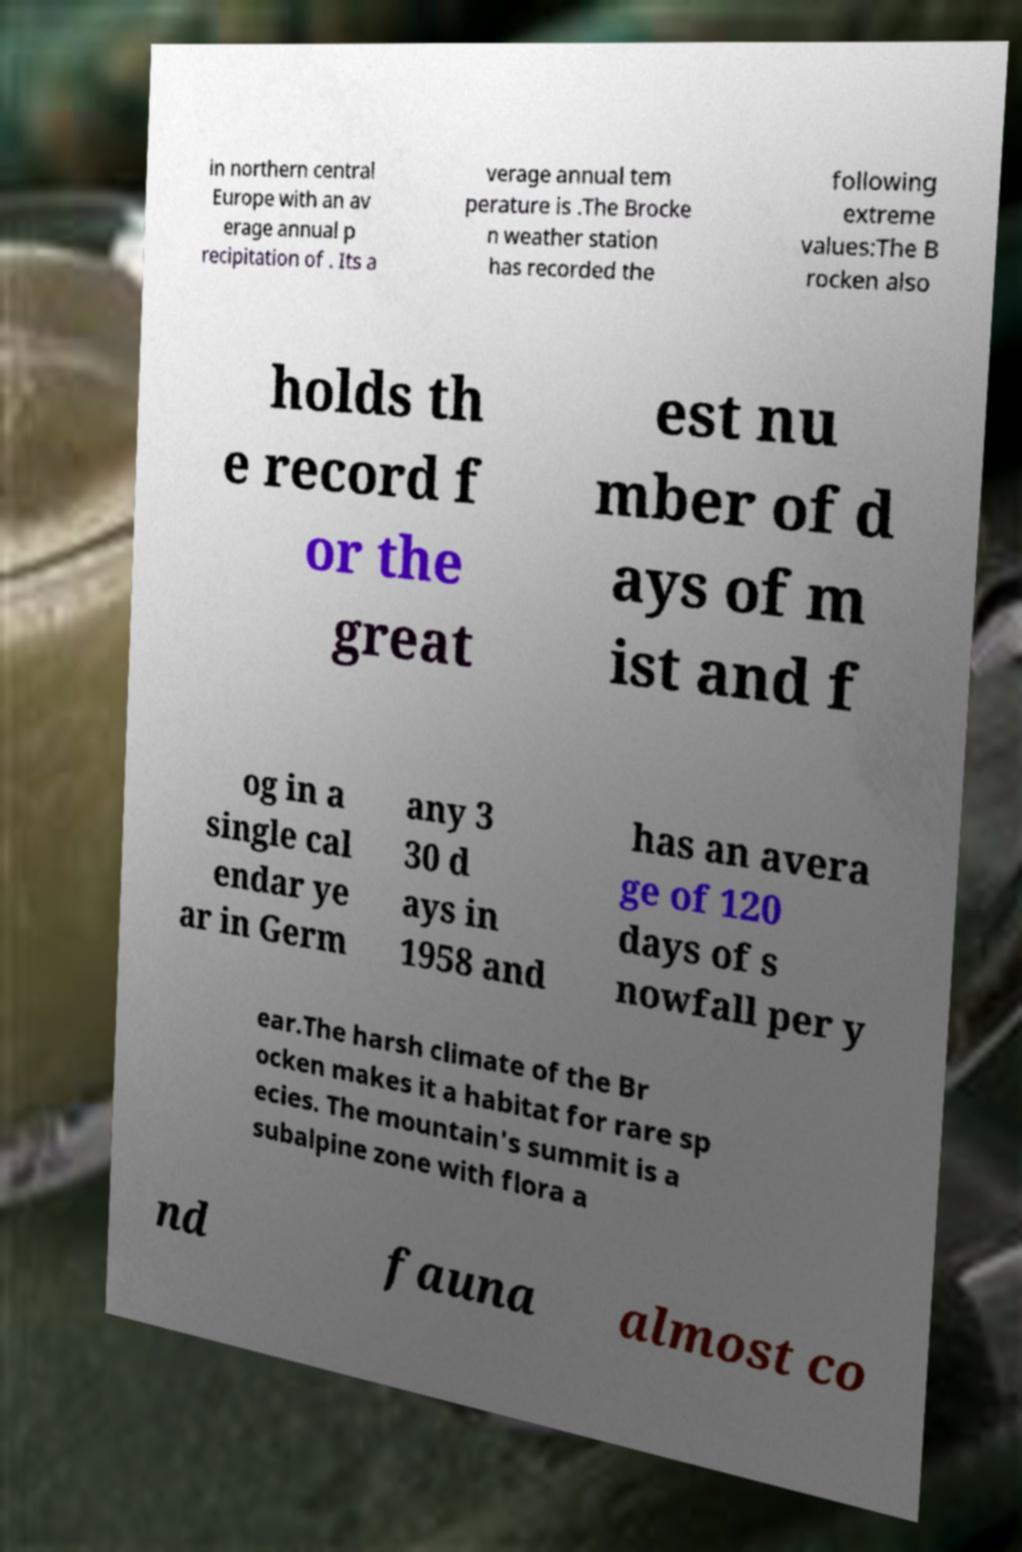Could you extract and type out the text from this image? in northern central Europe with an av erage annual p recipitation of . Its a verage annual tem perature is .The Brocke n weather station has recorded the following extreme values:The B rocken also holds th e record f or the great est nu mber of d ays of m ist and f og in a single cal endar ye ar in Germ any 3 30 d ays in 1958 and has an avera ge of 120 days of s nowfall per y ear.The harsh climate of the Br ocken makes it a habitat for rare sp ecies. The mountain's summit is a subalpine zone with flora a nd fauna almost co 